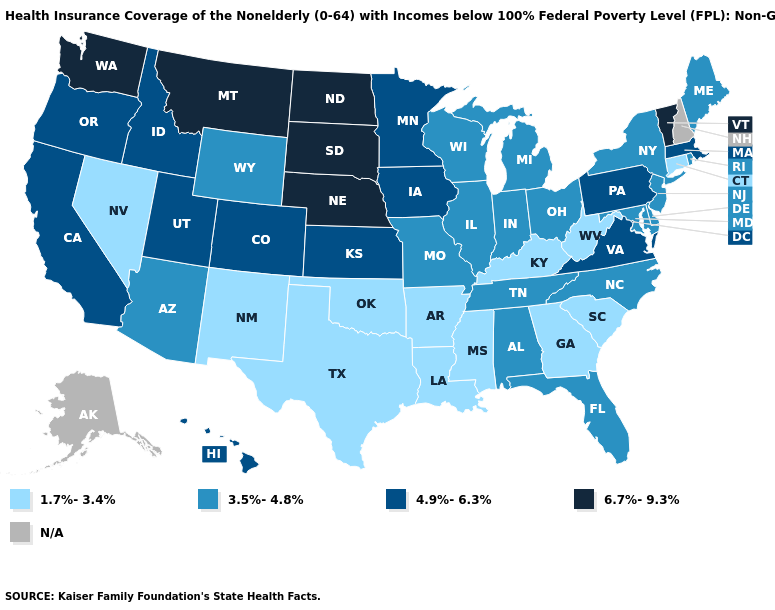What is the lowest value in the MidWest?
Short answer required. 3.5%-4.8%. Does Washington have the highest value in the USA?
Write a very short answer. Yes. What is the value of Hawaii?
Write a very short answer. 4.9%-6.3%. How many symbols are there in the legend?
Answer briefly. 5. Name the states that have a value in the range 1.7%-3.4%?
Give a very brief answer. Arkansas, Connecticut, Georgia, Kentucky, Louisiana, Mississippi, Nevada, New Mexico, Oklahoma, South Carolina, Texas, West Virginia. What is the highest value in states that border Connecticut?
Keep it brief. 4.9%-6.3%. What is the highest value in states that border Utah?
Give a very brief answer. 4.9%-6.3%. What is the value of New Mexico?
Keep it brief. 1.7%-3.4%. Name the states that have a value in the range 6.7%-9.3%?
Write a very short answer. Montana, Nebraska, North Dakota, South Dakota, Vermont, Washington. Does Illinois have the highest value in the MidWest?
Answer briefly. No. Does Washington have the lowest value in the West?
Quick response, please. No. What is the lowest value in the Northeast?
Be succinct. 1.7%-3.4%. Does Tennessee have the highest value in the USA?
Concise answer only. No. What is the lowest value in the West?
Concise answer only. 1.7%-3.4%. Does Virginia have the highest value in the South?
Concise answer only. Yes. 